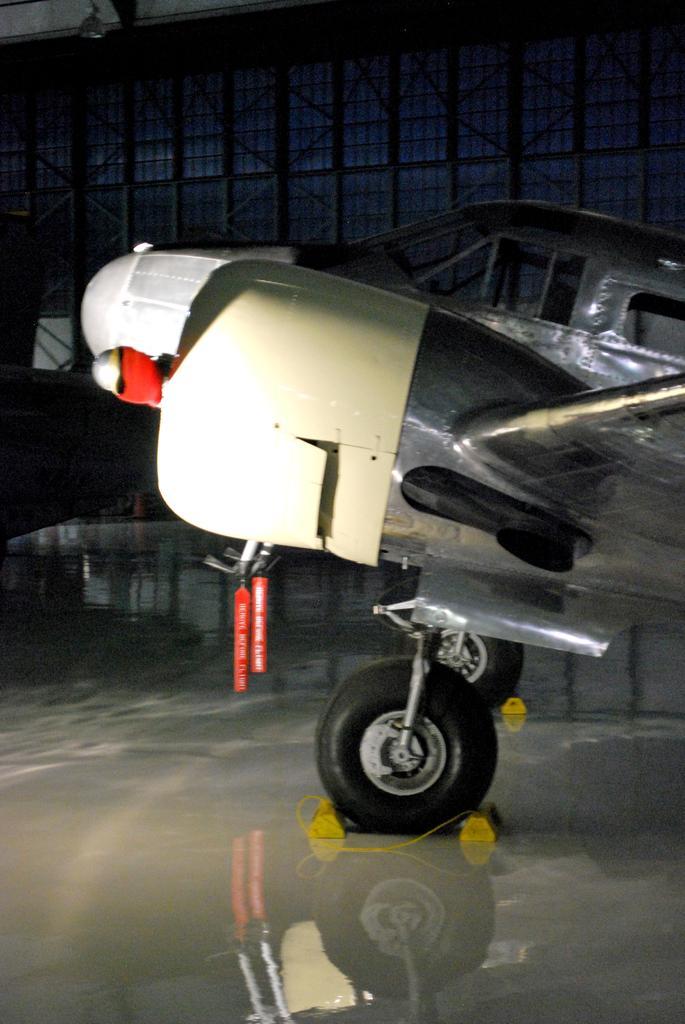Please provide a concise description of this image. This image consists of a jet plane parked on the road. At the bottom, there is a floor. In the background, there is a wall. The plane is in white color. 